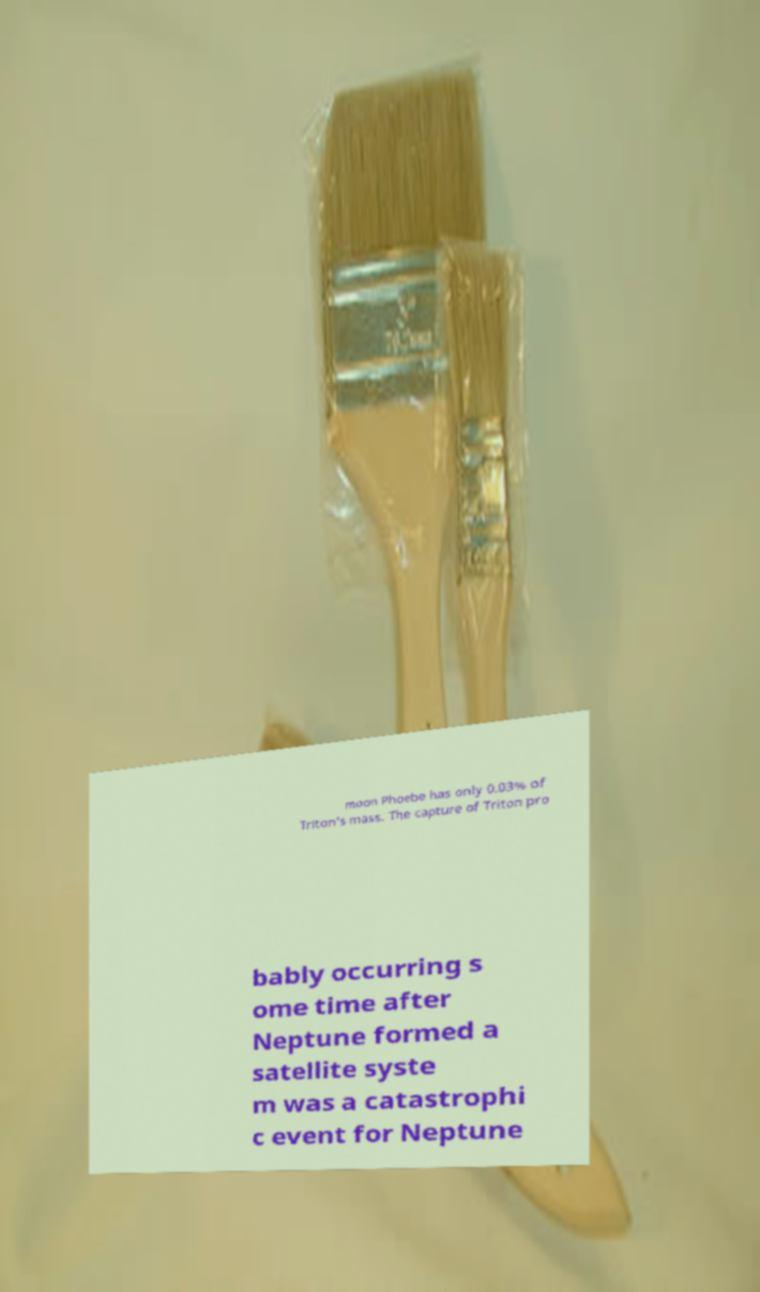Can you read and provide the text displayed in the image?This photo seems to have some interesting text. Can you extract and type it out for me? moon Phoebe has only 0.03% of Triton's mass. The capture of Triton pro bably occurring s ome time after Neptune formed a satellite syste m was a catastrophi c event for Neptune 